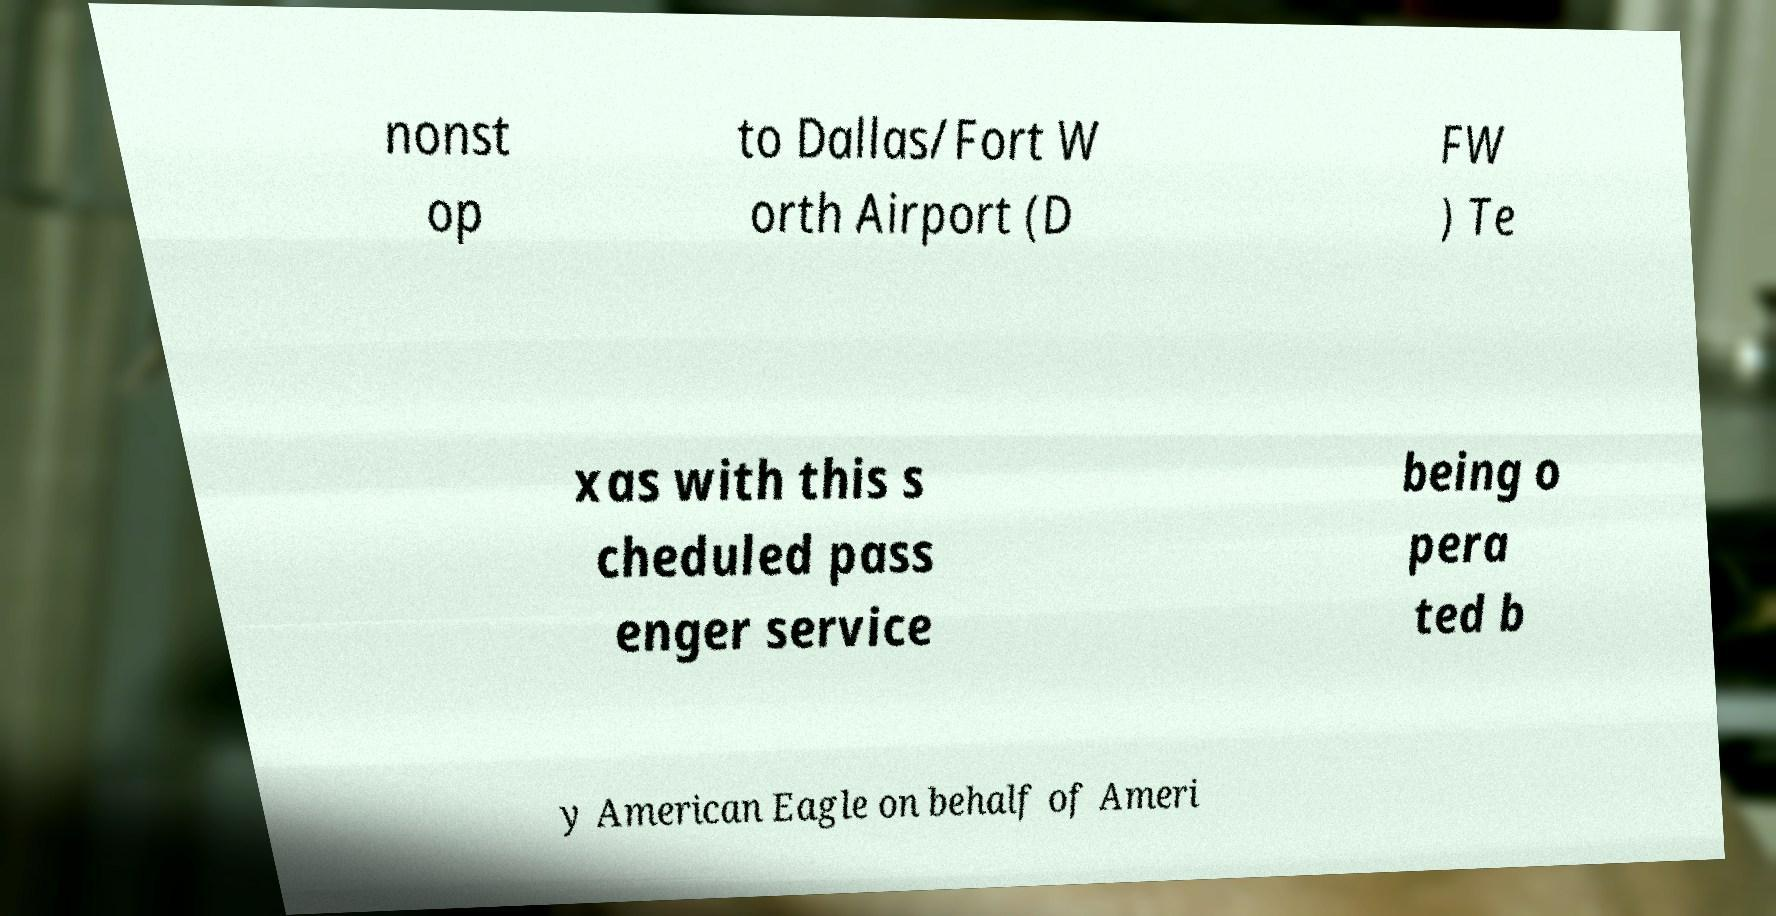I need the written content from this picture converted into text. Can you do that? nonst op to Dallas/Fort W orth Airport (D FW ) Te xas with this s cheduled pass enger service being o pera ted b y American Eagle on behalf of Ameri 